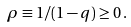<formula> <loc_0><loc_0><loc_500><loc_500>\rho \equiv 1 / ( 1 - q ) \geq 0 \, .</formula> 